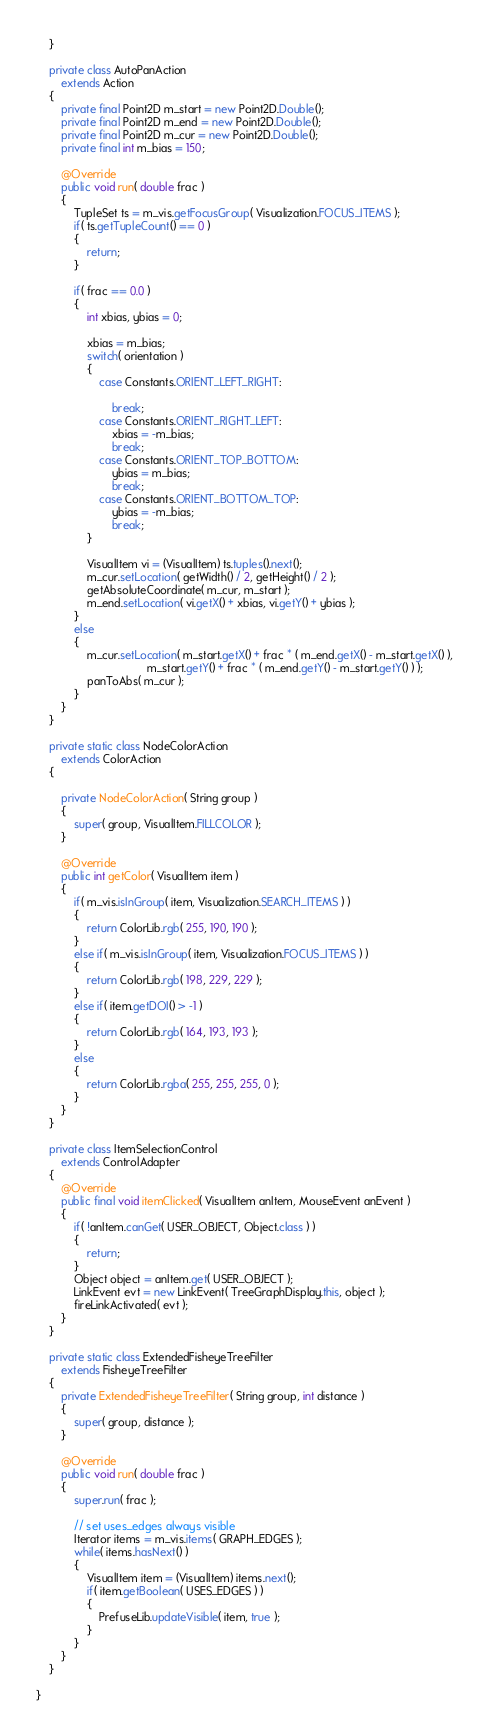<code> <loc_0><loc_0><loc_500><loc_500><_Java_>    }

    private class AutoPanAction
        extends Action
    {
        private final Point2D m_start = new Point2D.Double();
        private final Point2D m_end = new Point2D.Double();
        private final Point2D m_cur = new Point2D.Double();
        private final int m_bias = 150;

        @Override
        public void run( double frac )
        {
            TupleSet ts = m_vis.getFocusGroup( Visualization.FOCUS_ITEMS );
            if( ts.getTupleCount() == 0 )
            {
                return;
            }

            if( frac == 0.0 )
            {
                int xbias, ybias = 0;

                xbias = m_bias;
                switch( orientation )
                {
                    case Constants.ORIENT_LEFT_RIGHT:

                        break;
                    case Constants.ORIENT_RIGHT_LEFT:
                        xbias = -m_bias;
                        break;
                    case Constants.ORIENT_TOP_BOTTOM:
                        ybias = m_bias;
                        break;
                    case Constants.ORIENT_BOTTOM_TOP:
                        ybias = -m_bias;
                        break;
                }

                VisualItem vi = (VisualItem) ts.tuples().next();
                m_cur.setLocation( getWidth() / 2, getHeight() / 2 );
                getAbsoluteCoordinate( m_cur, m_start );
                m_end.setLocation( vi.getX() + xbias, vi.getY() + ybias );
            }
            else
            {
                m_cur.setLocation( m_start.getX() + frac * ( m_end.getX() - m_start.getX() ),
                                   m_start.getY() + frac * ( m_end.getY() - m_start.getY() ) );
                panToAbs( m_cur );
            }
        }
    }

    private static class NodeColorAction
        extends ColorAction
    {

        private NodeColorAction( String group )
        {
            super( group, VisualItem.FILLCOLOR );
        }

        @Override
        public int getColor( VisualItem item )
        {
            if( m_vis.isInGroup( item, Visualization.SEARCH_ITEMS ) )
            {
                return ColorLib.rgb( 255, 190, 190 );
            }
            else if( m_vis.isInGroup( item, Visualization.FOCUS_ITEMS ) )
            {
                return ColorLib.rgb( 198, 229, 229 );
            }
            else if( item.getDOI() > -1 )
            {
                return ColorLib.rgb( 164, 193, 193 );
            }
            else
            {
                return ColorLib.rgba( 255, 255, 255, 0 );
            }
        }
    }

    private class ItemSelectionControl
        extends ControlAdapter
    {
        @Override
        public final void itemClicked( VisualItem anItem, MouseEvent anEvent )
        {
            if( !anItem.canGet( USER_OBJECT, Object.class ) )
            {
                return;
            }
            Object object = anItem.get( USER_OBJECT );
            LinkEvent evt = new LinkEvent( TreeGraphDisplay.this, object );
            fireLinkActivated( evt );
        }
    }

    private static class ExtendedFisheyeTreeFilter
        extends FisheyeTreeFilter
    {
        private ExtendedFisheyeTreeFilter( String group, int distance )
        {
            super( group, distance );
        }

        @Override
        public void run( double frac )
        {
            super.run( frac );

            // set uses_edges always visible
            Iterator items = m_vis.items( GRAPH_EDGES );
            while( items.hasNext() )
            {
                VisualItem item = (VisualItem) items.next();
                if( item.getBoolean( USES_EDGES ) )
                {
                    PrefuseLib.updateVisible( item, true );
                }
            }
        }
    }

}
</code> 